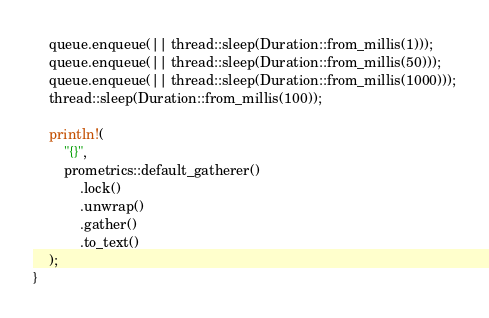<code> <loc_0><loc_0><loc_500><loc_500><_Rust_>    queue.enqueue(|| thread::sleep(Duration::from_millis(1)));
    queue.enqueue(|| thread::sleep(Duration::from_millis(50)));
    queue.enqueue(|| thread::sleep(Duration::from_millis(1000)));
    thread::sleep(Duration::from_millis(100));

    println!(
        "{}",
        prometrics::default_gatherer()
            .lock()
            .unwrap()
            .gather()
            .to_text()
    );
}
</code> 